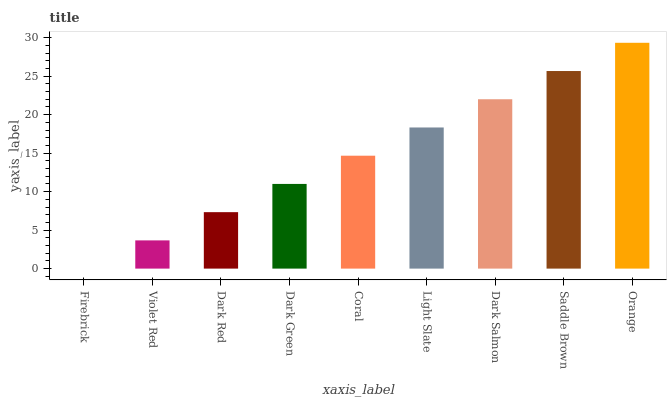Is Firebrick the minimum?
Answer yes or no. Yes. Is Orange the maximum?
Answer yes or no. Yes. Is Violet Red the minimum?
Answer yes or no. No. Is Violet Red the maximum?
Answer yes or no. No. Is Violet Red greater than Firebrick?
Answer yes or no. Yes. Is Firebrick less than Violet Red?
Answer yes or no. Yes. Is Firebrick greater than Violet Red?
Answer yes or no. No. Is Violet Red less than Firebrick?
Answer yes or no. No. Is Coral the high median?
Answer yes or no. Yes. Is Coral the low median?
Answer yes or no. Yes. Is Orange the high median?
Answer yes or no. No. Is Orange the low median?
Answer yes or no. No. 